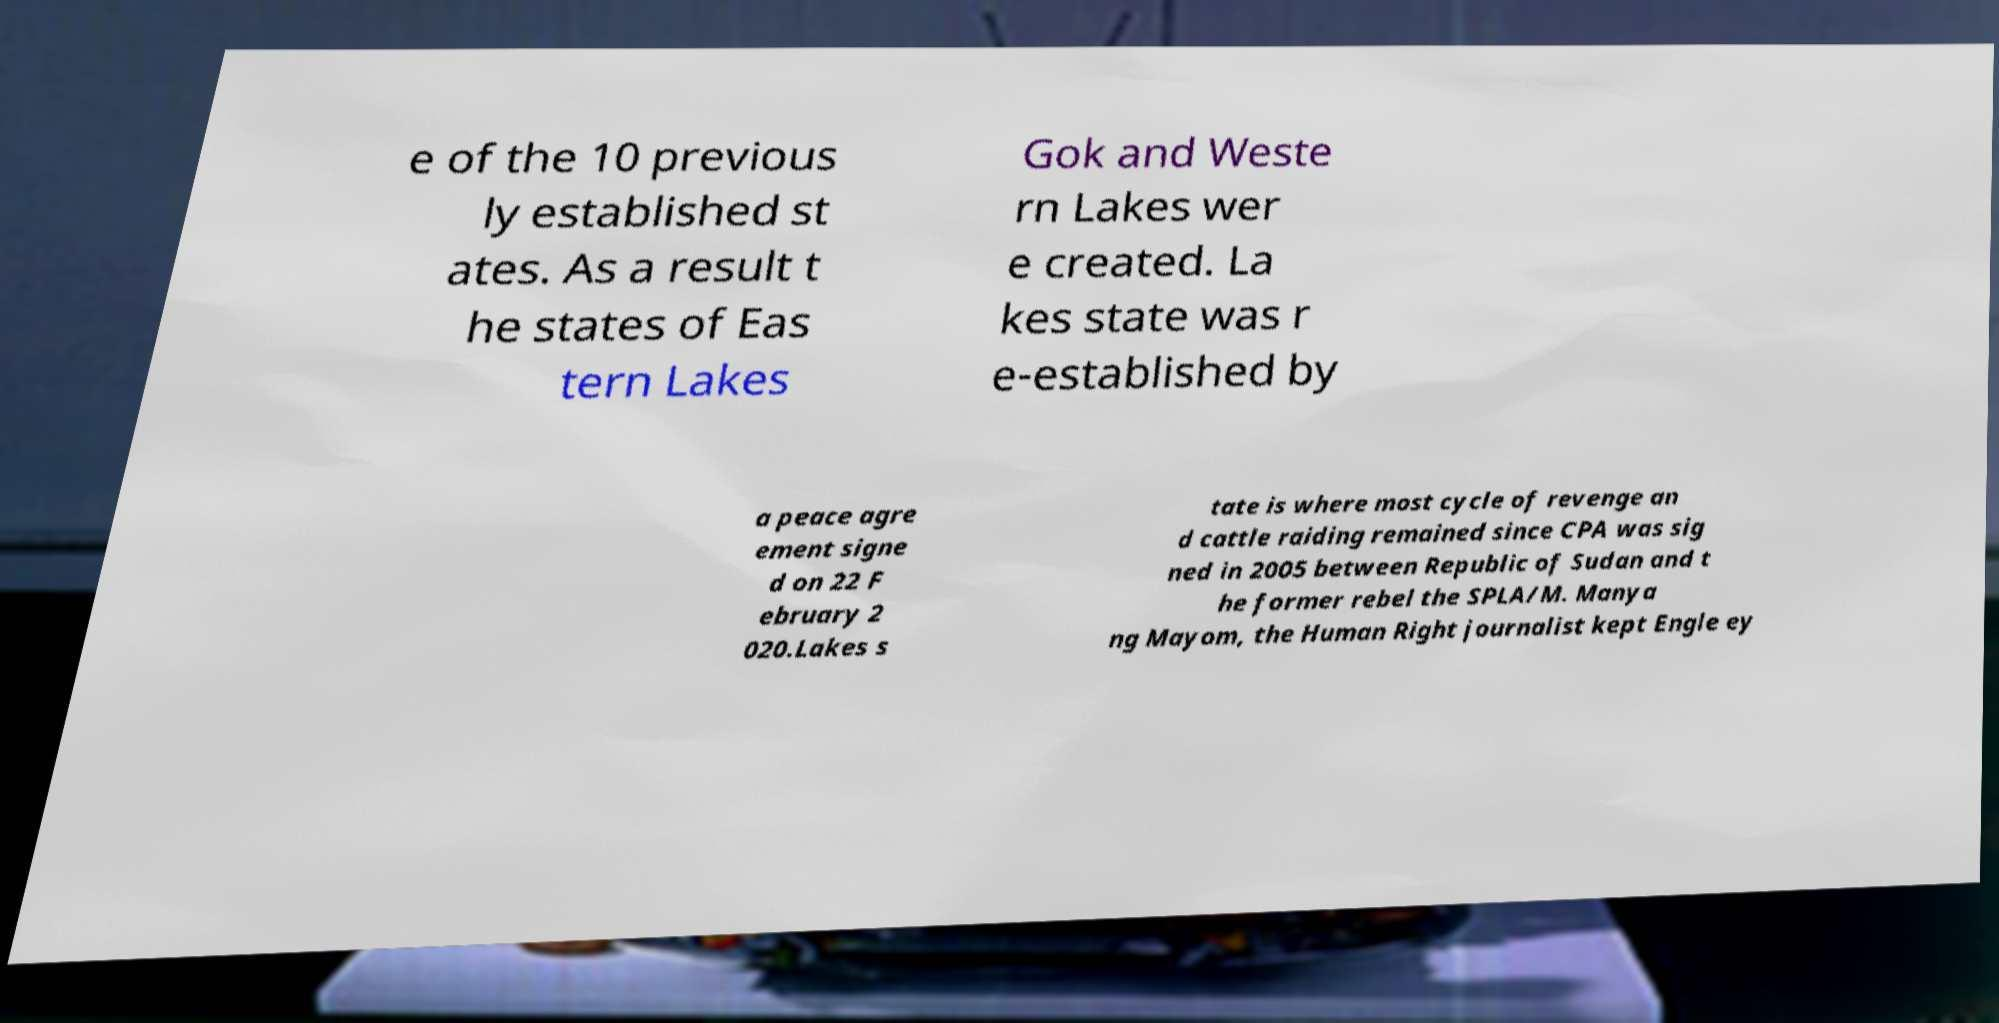For documentation purposes, I need the text within this image transcribed. Could you provide that? e of the 10 previous ly established st ates. As a result t he states of Eas tern Lakes Gok and Weste rn Lakes wer e created. La kes state was r e-established by a peace agre ement signe d on 22 F ebruary 2 020.Lakes s tate is where most cycle of revenge an d cattle raiding remained since CPA was sig ned in 2005 between Republic of Sudan and t he former rebel the SPLA/M. Manya ng Mayom, the Human Right journalist kept Engle ey 